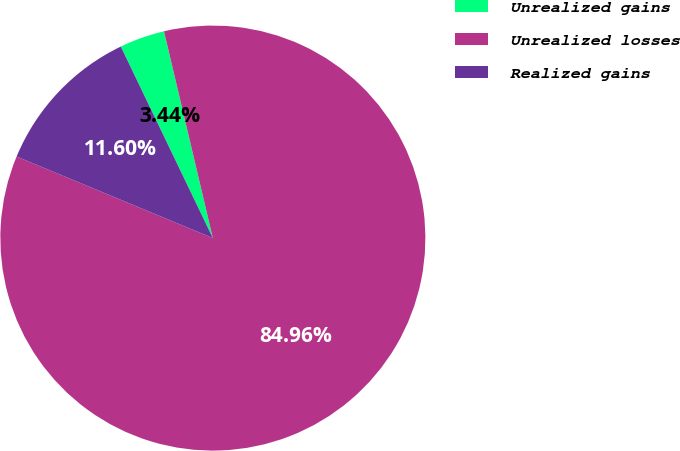Convert chart. <chart><loc_0><loc_0><loc_500><loc_500><pie_chart><fcel>Unrealized gains<fcel>Unrealized losses<fcel>Realized gains<nl><fcel>3.44%<fcel>84.96%<fcel>11.6%<nl></chart> 